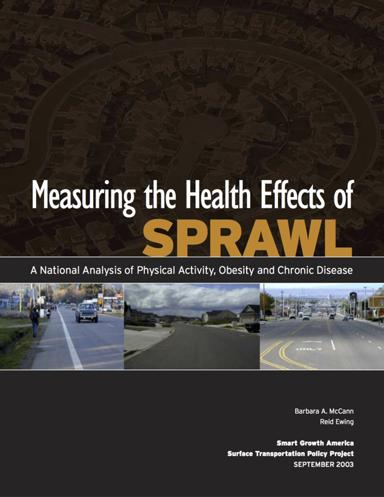Who are the authors of this national analysis? This insightful analysis is authored by Barbara A. McCann, known for her expertise in urban planning, and Reid Ewing, a distinguished professor specializing in environmental and urban planning. 